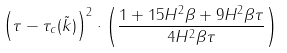Convert formula to latex. <formula><loc_0><loc_0><loc_500><loc_500>\left ( \tau - \tau _ { c } ( \tilde { k } ) \right ) ^ { 2 } \cdot \left ( \frac { 1 + 1 5 H ^ { 2 } \beta + 9 H ^ { 2 } \beta \tau } { 4 H ^ { 2 } \beta \tau } \right )</formula> 